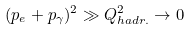<formula> <loc_0><loc_0><loc_500><loc_500>( p _ { e } + p _ { \gamma } ) ^ { 2 } \gg Q ^ { 2 } _ { h a d r . } \rightarrow 0</formula> 